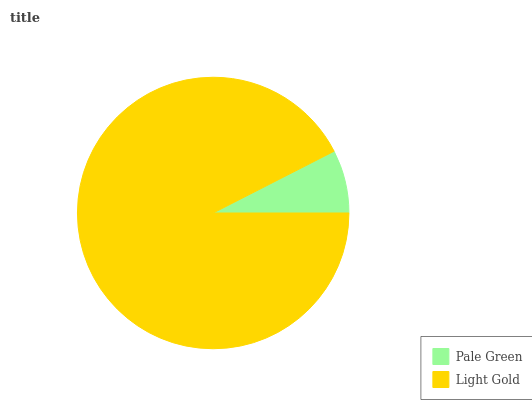Is Pale Green the minimum?
Answer yes or no. Yes. Is Light Gold the maximum?
Answer yes or no. Yes. Is Light Gold the minimum?
Answer yes or no. No. Is Light Gold greater than Pale Green?
Answer yes or no. Yes. Is Pale Green less than Light Gold?
Answer yes or no. Yes. Is Pale Green greater than Light Gold?
Answer yes or no. No. Is Light Gold less than Pale Green?
Answer yes or no. No. Is Light Gold the high median?
Answer yes or no. Yes. Is Pale Green the low median?
Answer yes or no. Yes. Is Pale Green the high median?
Answer yes or no. No. Is Light Gold the low median?
Answer yes or no. No. 